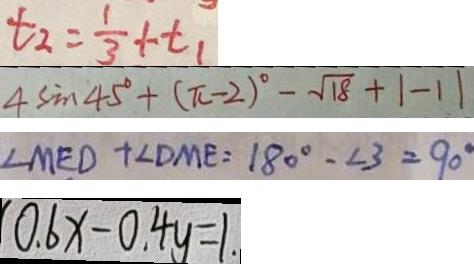Convert formula to latex. <formula><loc_0><loc_0><loc_500><loc_500>t _ { 2 } = \frac { 1 } { 3 } + t _ { 1 } 
 4 \sin 4 5 ^ { \circ } + ( \pi - 2 ) ^ { \circ } - \sqrt { 1 8 } + 1 - 1 1 
 \angle M E D + \angle D M E = 1 8 0 ^ { \circ } - \angle 3 = 9 0 ^ { \circ } 
 0 . 6 x - 0 . 4 y = 1 .</formula> 